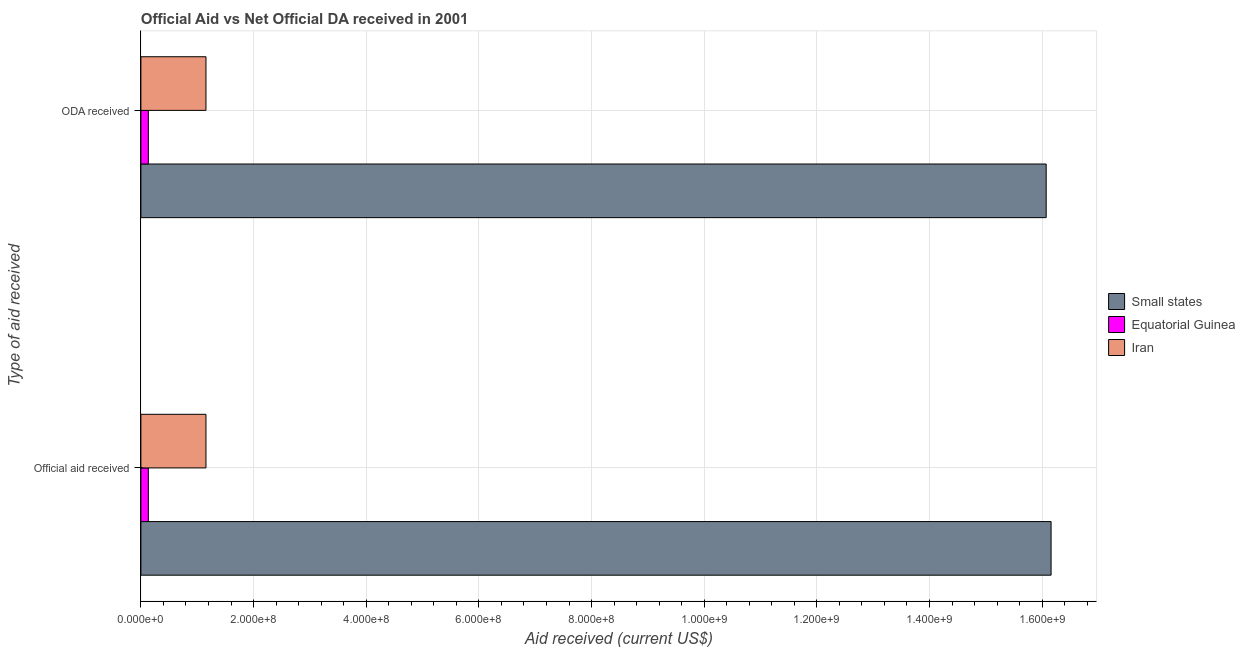Are the number of bars on each tick of the Y-axis equal?
Your answer should be very brief. Yes. What is the label of the 2nd group of bars from the top?
Give a very brief answer. Official aid received. What is the official aid received in Equatorial Guinea?
Provide a short and direct response. 1.32e+07. Across all countries, what is the maximum oda received?
Ensure brevity in your answer.  1.61e+09. Across all countries, what is the minimum oda received?
Your answer should be compact. 1.32e+07. In which country was the official aid received maximum?
Give a very brief answer. Small states. In which country was the oda received minimum?
Offer a terse response. Equatorial Guinea. What is the total official aid received in the graph?
Keep it short and to the point. 1.74e+09. What is the difference between the oda received in Equatorial Guinea and that in Iran?
Provide a succinct answer. -1.02e+08. What is the difference between the oda received in Iran and the official aid received in Small states?
Offer a very short reply. -1.50e+09. What is the average oda received per country?
Your response must be concise. 5.79e+08. In how many countries, is the official aid received greater than 440000000 US$?
Offer a very short reply. 1. What is the ratio of the official aid received in Equatorial Guinea to that in Small states?
Offer a very short reply. 0.01. What does the 3rd bar from the top in ODA received represents?
Your answer should be compact. Small states. What does the 1st bar from the bottom in Official aid received represents?
Offer a terse response. Small states. How many bars are there?
Give a very brief answer. 6. Are all the bars in the graph horizontal?
Provide a short and direct response. Yes. Are the values on the major ticks of X-axis written in scientific E-notation?
Offer a very short reply. Yes. Does the graph contain grids?
Give a very brief answer. Yes. How are the legend labels stacked?
Provide a succinct answer. Vertical. What is the title of the graph?
Give a very brief answer. Official Aid vs Net Official DA received in 2001 . Does "Syrian Arab Republic" appear as one of the legend labels in the graph?
Offer a terse response. No. What is the label or title of the X-axis?
Provide a short and direct response. Aid received (current US$). What is the label or title of the Y-axis?
Offer a very short reply. Type of aid received. What is the Aid received (current US$) of Small states in Official aid received?
Your answer should be compact. 1.62e+09. What is the Aid received (current US$) in Equatorial Guinea in Official aid received?
Keep it short and to the point. 1.32e+07. What is the Aid received (current US$) of Iran in Official aid received?
Give a very brief answer. 1.16e+08. What is the Aid received (current US$) in Small states in ODA received?
Offer a very short reply. 1.61e+09. What is the Aid received (current US$) in Equatorial Guinea in ODA received?
Your answer should be very brief. 1.32e+07. What is the Aid received (current US$) of Iran in ODA received?
Offer a terse response. 1.16e+08. Across all Type of aid received, what is the maximum Aid received (current US$) in Small states?
Keep it short and to the point. 1.62e+09. Across all Type of aid received, what is the maximum Aid received (current US$) in Equatorial Guinea?
Provide a succinct answer. 1.32e+07. Across all Type of aid received, what is the maximum Aid received (current US$) of Iran?
Offer a terse response. 1.16e+08. Across all Type of aid received, what is the minimum Aid received (current US$) of Small states?
Ensure brevity in your answer.  1.61e+09. Across all Type of aid received, what is the minimum Aid received (current US$) of Equatorial Guinea?
Make the answer very short. 1.32e+07. Across all Type of aid received, what is the minimum Aid received (current US$) of Iran?
Make the answer very short. 1.16e+08. What is the total Aid received (current US$) of Small states in the graph?
Give a very brief answer. 3.22e+09. What is the total Aid received (current US$) in Equatorial Guinea in the graph?
Provide a succinct answer. 2.65e+07. What is the total Aid received (current US$) of Iran in the graph?
Your answer should be very brief. 2.31e+08. What is the difference between the Aid received (current US$) of Small states in Official aid received and that in ODA received?
Offer a terse response. 8.68e+06. What is the difference between the Aid received (current US$) of Equatorial Guinea in Official aid received and that in ODA received?
Your answer should be compact. 0. What is the difference between the Aid received (current US$) in Small states in Official aid received and the Aid received (current US$) in Equatorial Guinea in ODA received?
Offer a terse response. 1.60e+09. What is the difference between the Aid received (current US$) of Small states in Official aid received and the Aid received (current US$) of Iran in ODA received?
Give a very brief answer. 1.50e+09. What is the difference between the Aid received (current US$) in Equatorial Guinea in Official aid received and the Aid received (current US$) in Iran in ODA received?
Offer a terse response. -1.02e+08. What is the average Aid received (current US$) of Small states per Type of aid received?
Your answer should be very brief. 1.61e+09. What is the average Aid received (current US$) in Equatorial Guinea per Type of aid received?
Offer a terse response. 1.32e+07. What is the average Aid received (current US$) in Iran per Type of aid received?
Provide a short and direct response. 1.16e+08. What is the difference between the Aid received (current US$) in Small states and Aid received (current US$) in Equatorial Guinea in Official aid received?
Ensure brevity in your answer.  1.60e+09. What is the difference between the Aid received (current US$) in Small states and Aid received (current US$) in Iran in Official aid received?
Offer a terse response. 1.50e+09. What is the difference between the Aid received (current US$) in Equatorial Guinea and Aid received (current US$) in Iran in Official aid received?
Provide a short and direct response. -1.02e+08. What is the difference between the Aid received (current US$) of Small states and Aid received (current US$) of Equatorial Guinea in ODA received?
Your response must be concise. 1.59e+09. What is the difference between the Aid received (current US$) in Small states and Aid received (current US$) in Iran in ODA received?
Make the answer very short. 1.49e+09. What is the difference between the Aid received (current US$) of Equatorial Guinea and Aid received (current US$) of Iran in ODA received?
Make the answer very short. -1.02e+08. What is the ratio of the Aid received (current US$) of Small states in Official aid received to that in ODA received?
Make the answer very short. 1.01. What is the ratio of the Aid received (current US$) in Equatorial Guinea in Official aid received to that in ODA received?
Give a very brief answer. 1. What is the difference between the highest and the second highest Aid received (current US$) of Small states?
Your answer should be very brief. 8.68e+06. What is the difference between the highest and the lowest Aid received (current US$) in Small states?
Provide a short and direct response. 8.68e+06. What is the difference between the highest and the lowest Aid received (current US$) in Iran?
Offer a terse response. 0. 